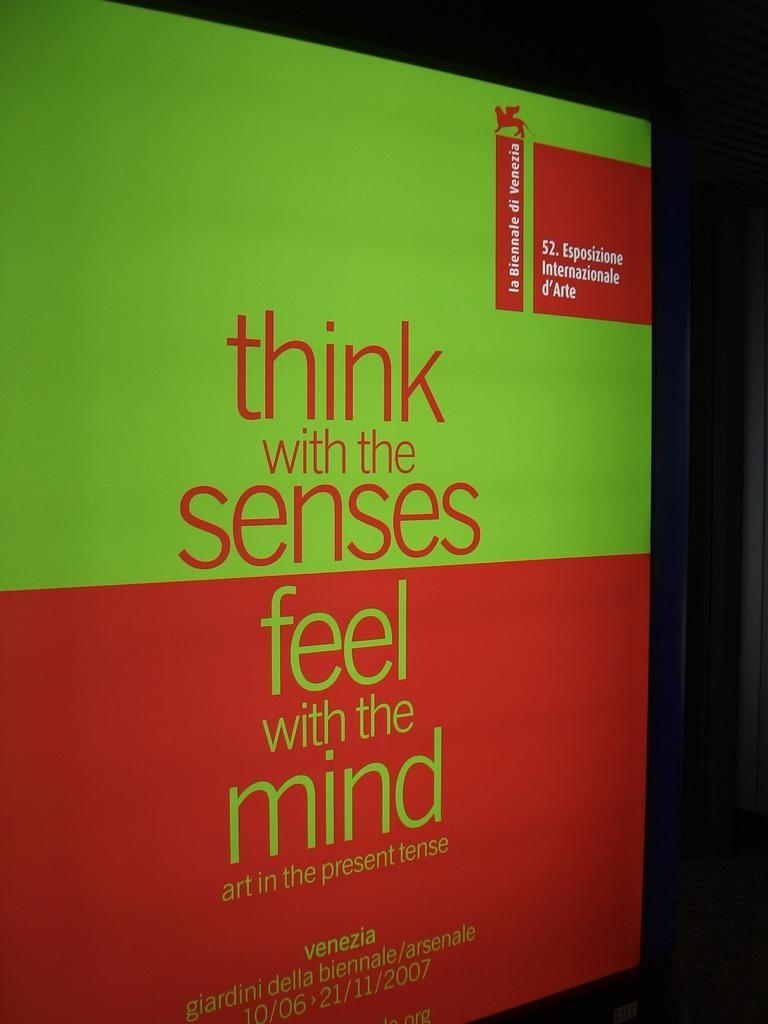<image>
Create a compact narrative representing the image presented. A red and green cover titled think with the senses feel with the mind. 